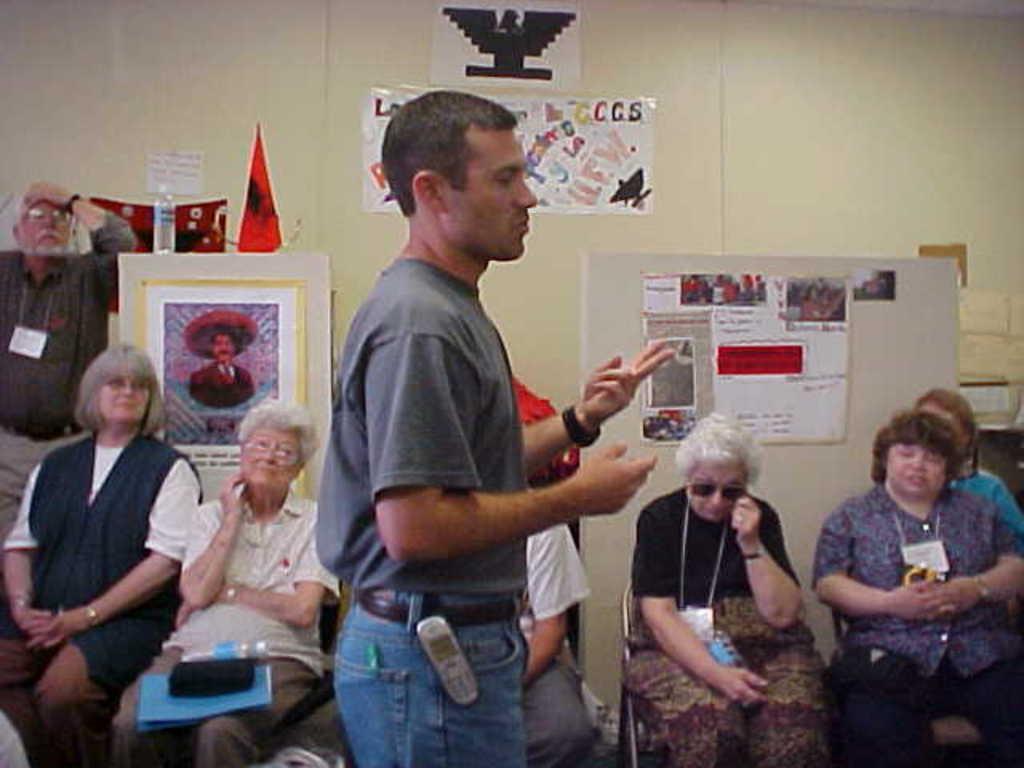Please provide a concise description of this image. On the left side of the image we can see two ladies are sitting on the chair and a man is standing. In the middle of the image we can see a person is standing and he kept the cell phone to his paint. On the right side of the image we can see three ladies are sitting on the chair and a board is there. 